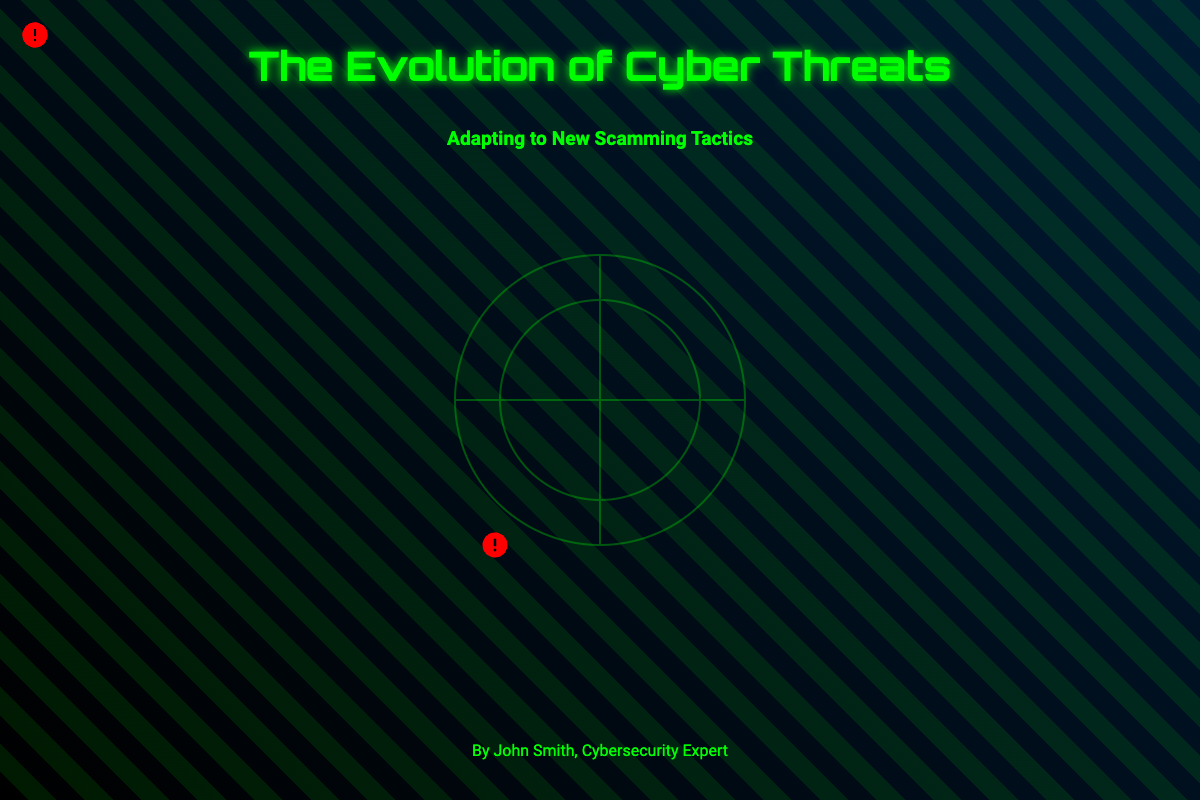What is the title of the book? The title is prominently displayed at the center of the book cover as "The Evolution of Cyber Threats".
Answer: The Evolution of Cyber Threats Who is the author? The author's name is shown at the bottom of the cover, indicating who wrote the book.
Answer: John Smith, Cybersecurity Expert What is the subtitle of the book? The subtitle is featured directly below the title, providing additional context about the book's content.
Answer: Adapting to New Scamming Tactics What color is the background of the book cover? The background color is a gradient that transitions from black to a dark blue shade.
Answer: Black to dark blue How many alert icons are on the cover? Upon examining the visual elements of the book cover, three alert icons are present.
Answer: Three What is the main theme of the book? The theme centers around understanding the changes and adaptations related to online scams.
Answer: Cyber threats and scamming tactics What design element is used to represent the globe? The globe is represented by an abstract design that includes circular lines and crosses in a light green stroke.
Answer: An abstract globe design What is the font style of the title? The title uses a distinctive font style that stands out on the cover, which is characterized as futuristic.
Answer: Orbitron What visual element appears as an overlay on the cover? A repeating linear design in green is used as the binary overlay, adding texture to the background.
Answer: Binary overlay What is the overall mood conveyed by the cover? The color scheme and design elements together create a futuristic and cautious mood, emphasizing urgency.
Answer: Futuristic and urgent 